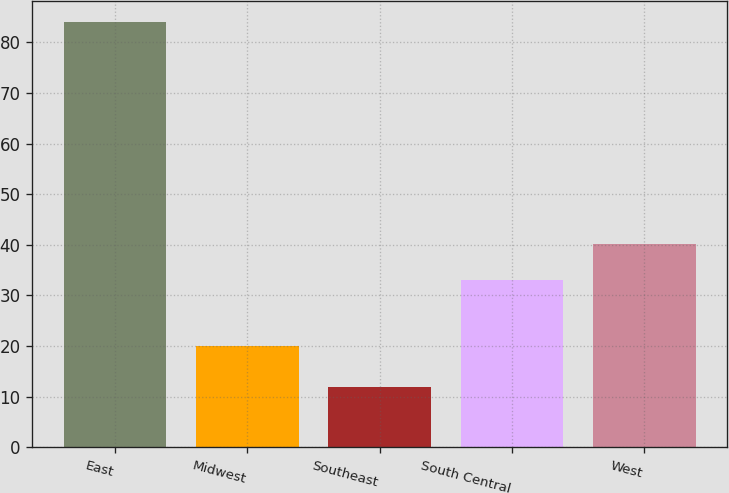Convert chart. <chart><loc_0><loc_0><loc_500><loc_500><bar_chart><fcel>East<fcel>Midwest<fcel>Southeast<fcel>South Central<fcel>West<nl><fcel>84<fcel>20<fcel>12<fcel>33<fcel>40.2<nl></chart> 